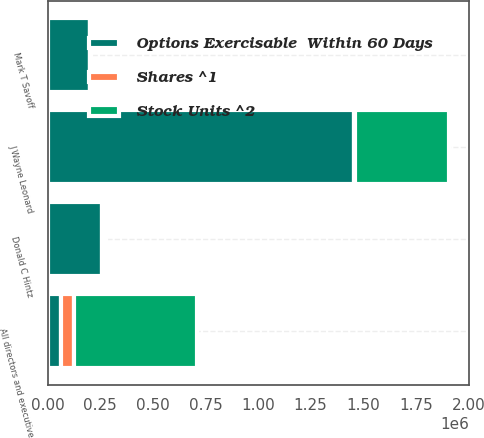Convert chart to OTSL. <chart><loc_0><loc_0><loc_500><loc_500><stacked_bar_chart><ecel><fcel>Donald C Hintz<fcel>J Wayne Leonard<fcel>Mark T Savoff<fcel>All directors and executive<nl><fcel>Stock Units ^2<fcel>8944<fcel>444898<fcel>4363<fcel>585170<nl><fcel>Options Exercisable  Within 60 Days<fcel>260000<fcel>1.45853e+06<fcel>199467<fcel>62543<nl><fcel>Shares ^1<fcel>6950<fcel>3111<fcel>263<fcel>62543<nl></chart> 